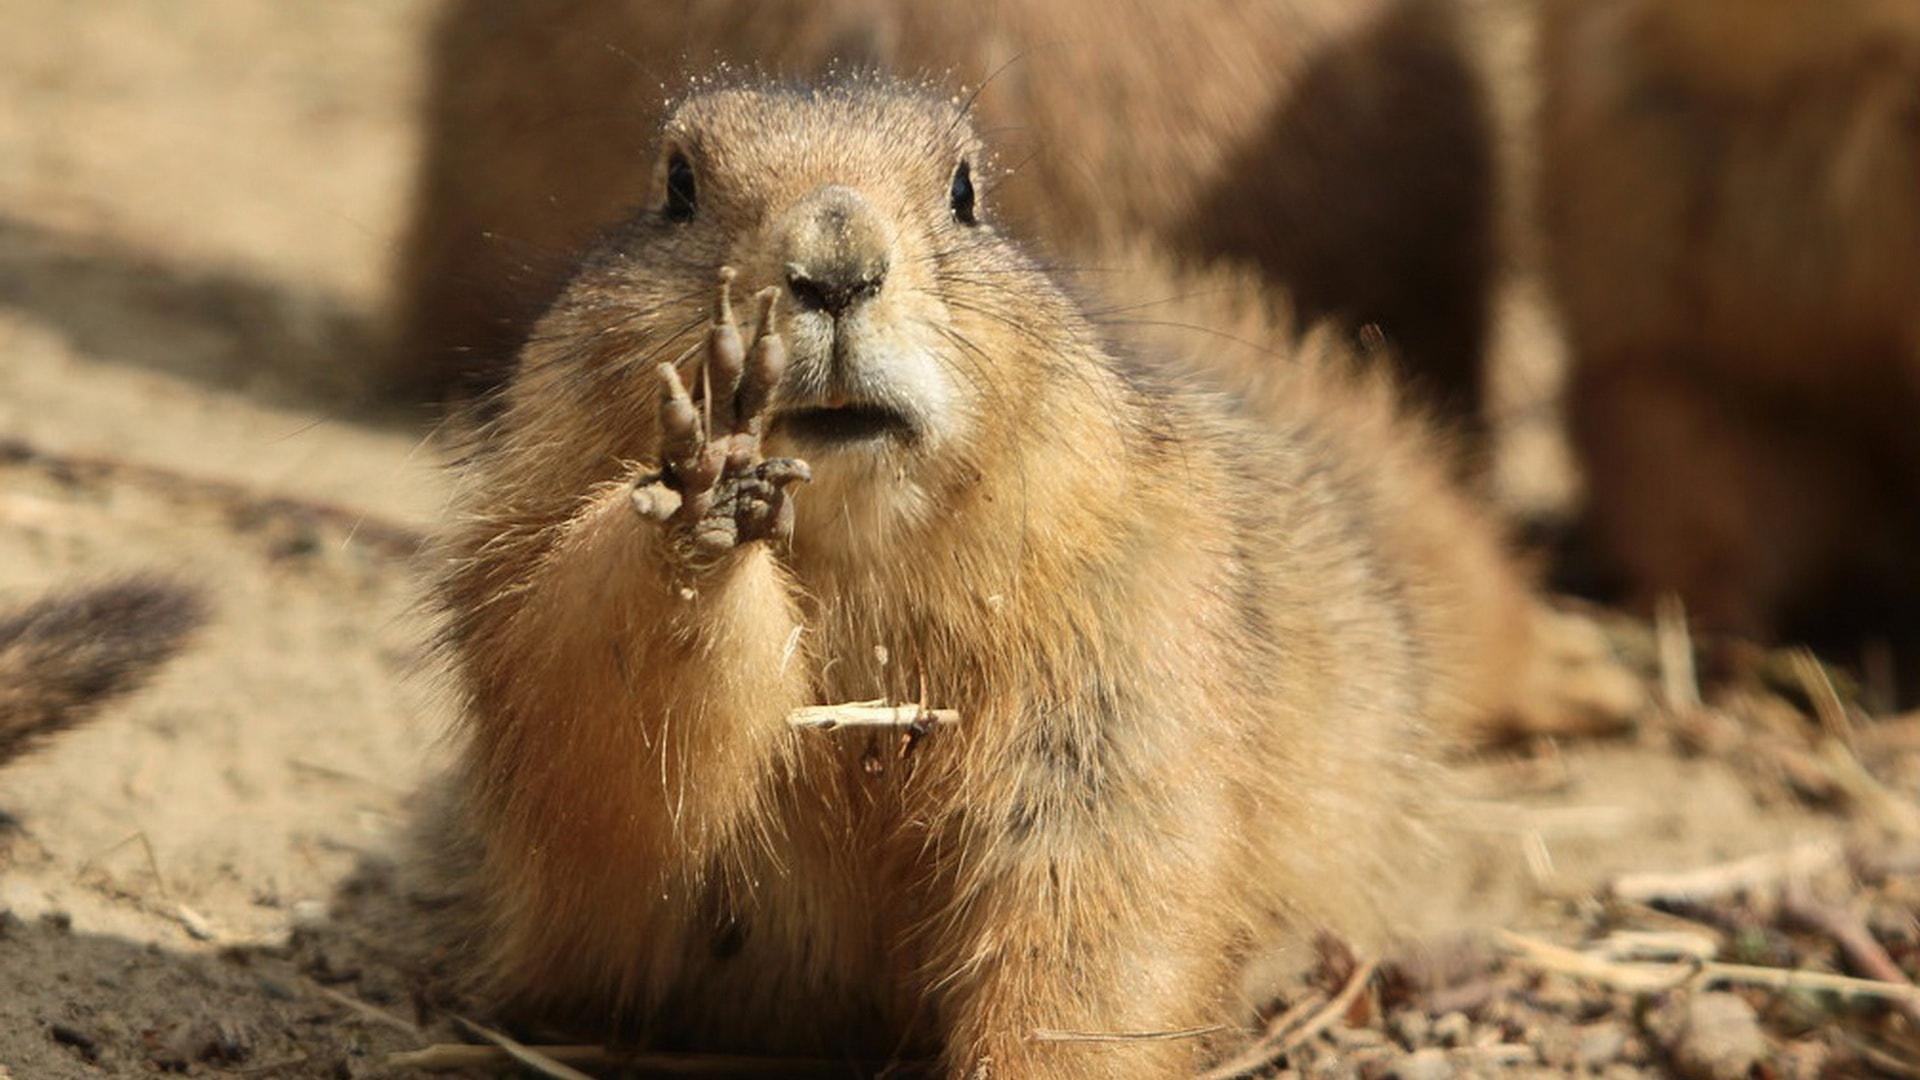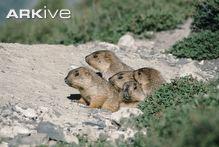The first image is the image on the left, the second image is the image on the right. Assess this claim about the two images: "The right image contains at least two rodents.". Correct or not? Answer yes or no. Yes. 